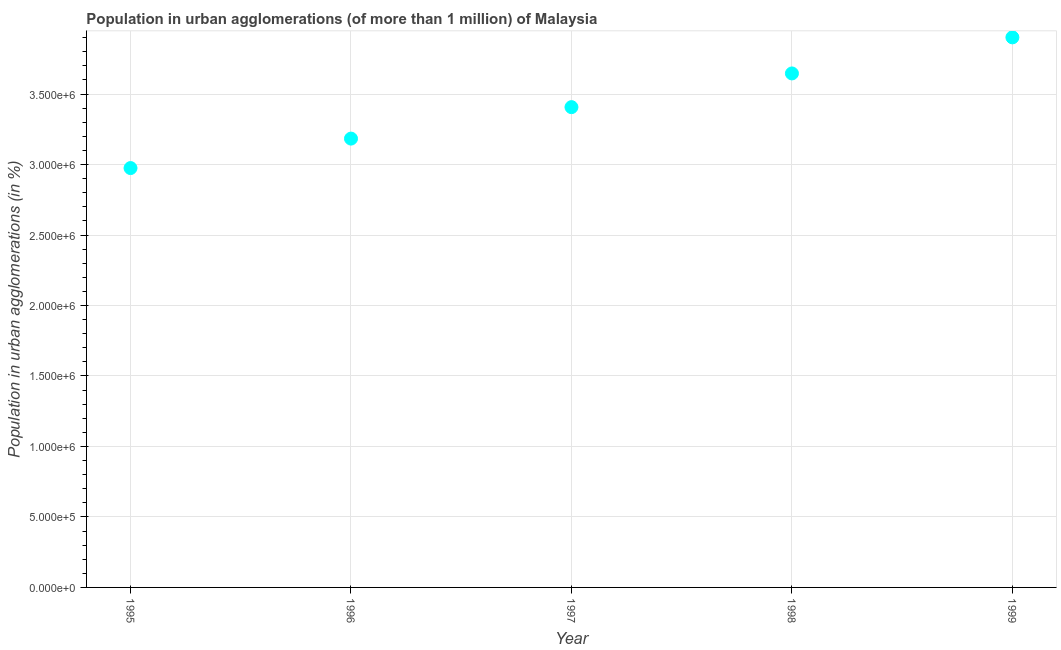What is the population in urban agglomerations in 1996?
Keep it short and to the point. 3.18e+06. Across all years, what is the maximum population in urban agglomerations?
Your answer should be compact. 3.90e+06. Across all years, what is the minimum population in urban agglomerations?
Your answer should be very brief. 2.97e+06. In which year was the population in urban agglomerations minimum?
Make the answer very short. 1995. What is the sum of the population in urban agglomerations?
Provide a short and direct response. 1.71e+07. What is the difference between the population in urban agglomerations in 1996 and 1997?
Provide a short and direct response. -2.23e+05. What is the average population in urban agglomerations per year?
Give a very brief answer. 3.42e+06. What is the median population in urban agglomerations?
Your answer should be very brief. 3.41e+06. What is the ratio of the population in urban agglomerations in 1997 to that in 1999?
Ensure brevity in your answer.  0.87. Is the difference between the population in urban agglomerations in 1995 and 1997 greater than the difference between any two years?
Offer a terse response. No. What is the difference between the highest and the second highest population in urban agglomerations?
Offer a very short reply. 2.56e+05. Is the sum of the population in urban agglomerations in 1996 and 1997 greater than the maximum population in urban agglomerations across all years?
Ensure brevity in your answer.  Yes. What is the difference between the highest and the lowest population in urban agglomerations?
Provide a succinct answer. 9.27e+05. Does the population in urban agglomerations monotonically increase over the years?
Keep it short and to the point. Yes. How many dotlines are there?
Keep it short and to the point. 1. Does the graph contain any zero values?
Offer a very short reply. No. What is the title of the graph?
Offer a terse response. Population in urban agglomerations (of more than 1 million) of Malaysia. What is the label or title of the Y-axis?
Your response must be concise. Population in urban agglomerations (in %). What is the Population in urban agglomerations (in %) in 1995?
Ensure brevity in your answer.  2.97e+06. What is the Population in urban agglomerations (in %) in 1996?
Provide a succinct answer. 3.18e+06. What is the Population in urban agglomerations (in %) in 1997?
Keep it short and to the point. 3.41e+06. What is the Population in urban agglomerations (in %) in 1998?
Your answer should be very brief. 3.65e+06. What is the Population in urban agglomerations (in %) in 1999?
Provide a short and direct response. 3.90e+06. What is the difference between the Population in urban agglomerations (in %) in 1995 and 1996?
Make the answer very short. -2.09e+05. What is the difference between the Population in urban agglomerations (in %) in 1995 and 1997?
Offer a very short reply. -4.32e+05. What is the difference between the Population in urban agglomerations (in %) in 1995 and 1998?
Provide a short and direct response. -6.71e+05. What is the difference between the Population in urban agglomerations (in %) in 1995 and 1999?
Ensure brevity in your answer.  -9.27e+05. What is the difference between the Population in urban agglomerations (in %) in 1996 and 1997?
Offer a very short reply. -2.23e+05. What is the difference between the Population in urban agglomerations (in %) in 1996 and 1998?
Ensure brevity in your answer.  -4.62e+05. What is the difference between the Population in urban agglomerations (in %) in 1996 and 1999?
Your answer should be compact. -7.18e+05. What is the difference between the Population in urban agglomerations (in %) in 1997 and 1998?
Offer a very short reply. -2.39e+05. What is the difference between the Population in urban agglomerations (in %) in 1997 and 1999?
Ensure brevity in your answer.  -4.95e+05. What is the difference between the Population in urban agglomerations (in %) in 1998 and 1999?
Give a very brief answer. -2.56e+05. What is the ratio of the Population in urban agglomerations (in %) in 1995 to that in 1996?
Your answer should be very brief. 0.93. What is the ratio of the Population in urban agglomerations (in %) in 1995 to that in 1997?
Provide a short and direct response. 0.87. What is the ratio of the Population in urban agglomerations (in %) in 1995 to that in 1998?
Give a very brief answer. 0.82. What is the ratio of the Population in urban agglomerations (in %) in 1995 to that in 1999?
Offer a terse response. 0.76. What is the ratio of the Population in urban agglomerations (in %) in 1996 to that in 1997?
Give a very brief answer. 0.94. What is the ratio of the Population in urban agglomerations (in %) in 1996 to that in 1998?
Your answer should be compact. 0.87. What is the ratio of the Population in urban agglomerations (in %) in 1996 to that in 1999?
Keep it short and to the point. 0.82. What is the ratio of the Population in urban agglomerations (in %) in 1997 to that in 1998?
Keep it short and to the point. 0.93. What is the ratio of the Population in urban agglomerations (in %) in 1997 to that in 1999?
Offer a terse response. 0.87. What is the ratio of the Population in urban agglomerations (in %) in 1998 to that in 1999?
Your answer should be compact. 0.93. 